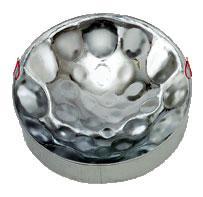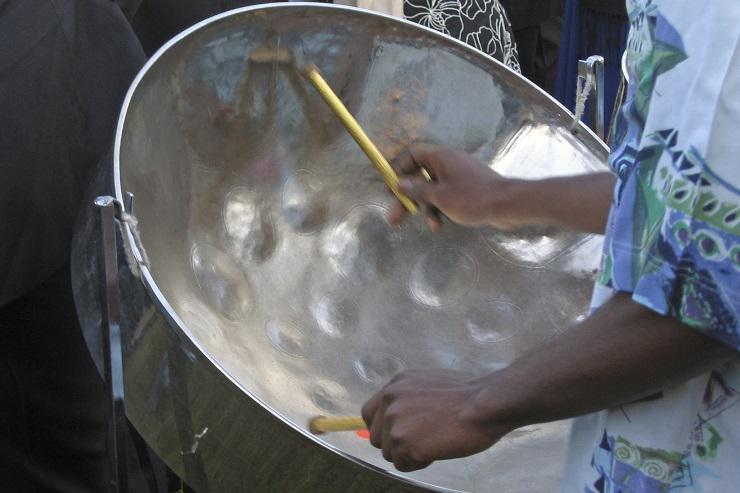The first image is the image on the left, the second image is the image on the right. Examine the images to the left and right. Is the description "One image features at least one steel drum with a concave hammered-look bowl, and the other image shows one person holding two drum sticks inside one drum's bowl." accurate? Answer yes or no. Yes. The first image is the image on the left, the second image is the image on the right. Analyze the images presented: Is the assertion "In exactly one image someone is playing steel drums." valid? Answer yes or no. Yes. 